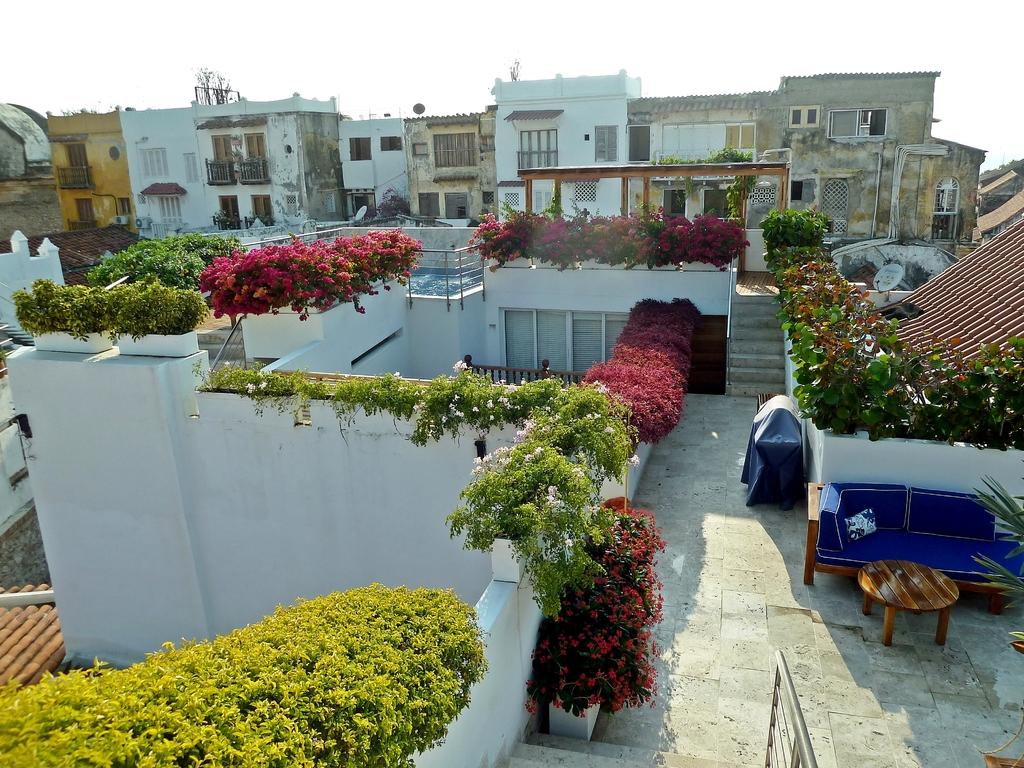What type of structures can be seen in the image? There are buildings in the image. What other elements are present in the image besides buildings? There are plants, flowers, a sofa, and a table in the image. How would you describe the weather in the image? The sky is cloudy in the image. Can you see a ring on the table in the image? There is no ring visible on the table in the image. Is there a train passing by in the image? There is no train present in the image. 